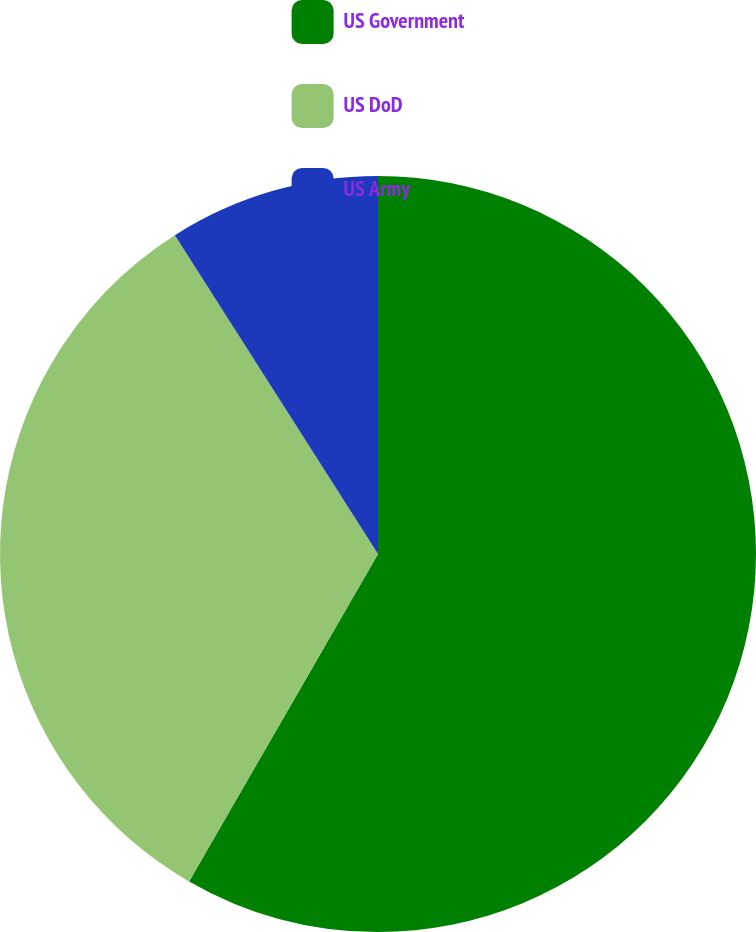Convert chart. <chart><loc_0><loc_0><loc_500><loc_500><pie_chart><fcel>US Government<fcel>US DoD<fcel>US Army<nl><fcel>58.33%<fcel>32.64%<fcel>9.03%<nl></chart> 